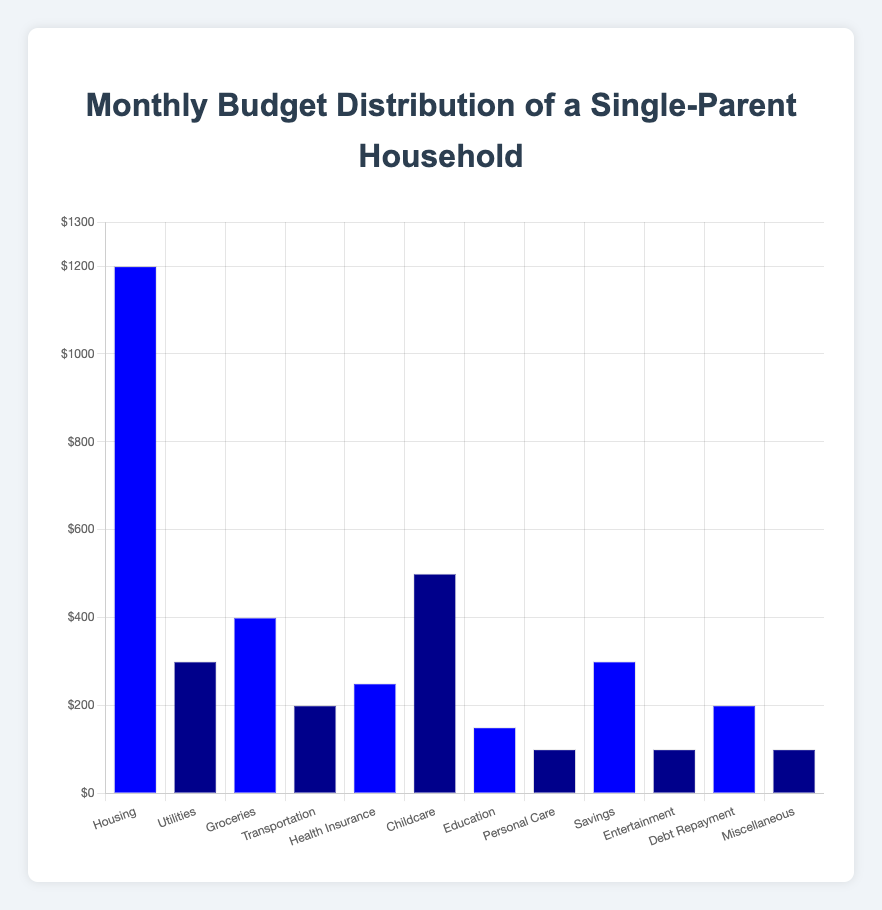Which category has the highest budget allocation? From the bar chart, observe the height of the bars and note that the highest bar represents the category with the highest allocation. The “Housing” category has the tallest bar.
Answer: Housing What is the total amount allocated to Utilities and Transportation? Locate the bars for "Utilities" and "Transportation," observe their heights which represent $300 and $200 respectively. Sum these two amounts: 300 + 200 = 500.
Answer: $500 Which categories have the same amount allocated, and what is that amount? Identify bars of equal height in the chart. "Personal Care", "Entertainment", and "Miscellaneous" all have bars of the same height, representing $100.
Answer: Personal Care, Entertainment, Miscellaneous - $100 How much more is allocated to Housing compared to Childcare? Find the heights of the "Housing" and "Childcare" bars representing $1200 and $500 respectively. Subtract the smaller from the larger value: 1200 - 500 = 700.
Answer: $700 What is the average budget allocation across all categories? Sum all the amounts and then divide by the number of categories. The sum is: 1200 + 300 + 400 + 200 + 250 + 500 + 150 + 100 + 300 + 100 + 200 + 100 = 3800. There are 12 categories. So, the average is 3800 / 12 = 316.67.
Answer: $316.67 Which category has a budget allocation closest to the average? With the average calculated as $316.67, compare each category’s allocation to the average. "Utilities" and "Savings" with $300 are closest to $316.67.
Answer: Utilities, Savings What is the difference between the highest and the lowest budget allocations? The highest allocation is for "Housing" ($1200) and the lowest allocations are for "Personal Care", "Entertainment", and "Miscellaneous" (each $100). Subtract the smallest from the largest: 1200 - 100 = 1100.
Answer: $1100 